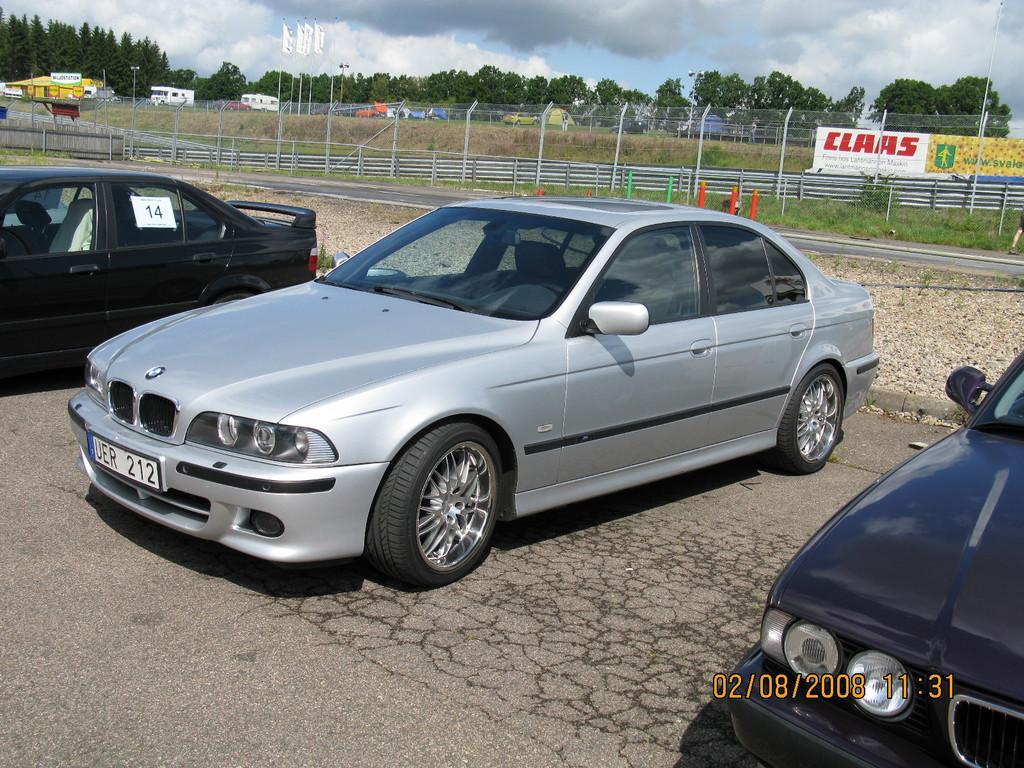Can you describe this image briefly? In this picture we can see cars on the road, fences, banners, trees, poles and in the background we can see the sky with clouds. 